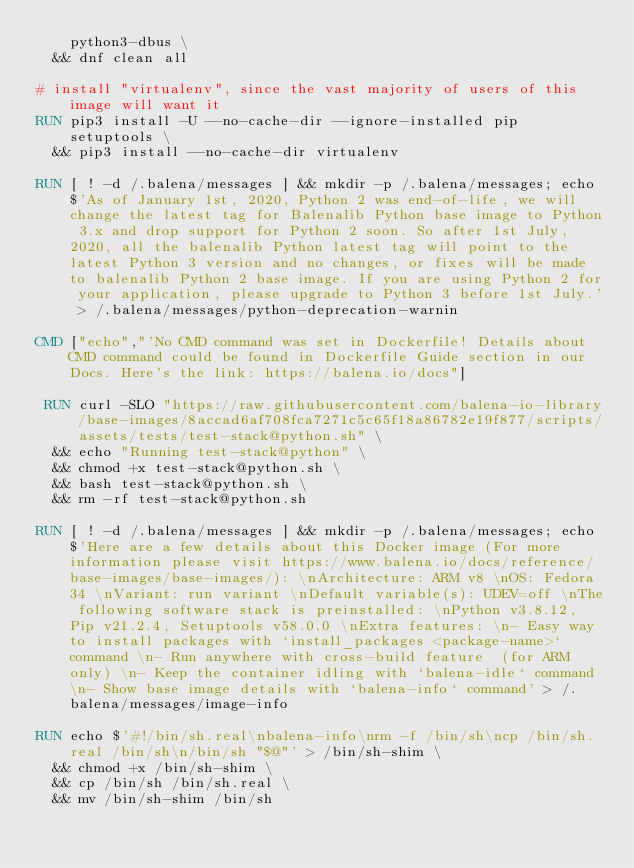<code> <loc_0><loc_0><loc_500><loc_500><_Dockerfile_>		python3-dbus \
	&& dnf clean all

# install "virtualenv", since the vast majority of users of this image will want it
RUN pip3 install -U --no-cache-dir --ignore-installed pip setuptools \
	&& pip3 install --no-cache-dir virtualenv

RUN [ ! -d /.balena/messages ] && mkdir -p /.balena/messages; echo $'As of January 1st, 2020, Python 2 was end-of-life, we will change the latest tag for Balenalib Python base image to Python 3.x and drop support for Python 2 soon. So after 1st July, 2020, all the balenalib Python latest tag will point to the latest Python 3 version and no changes, or fixes will be made to balenalib Python 2 base image. If you are using Python 2 for your application, please upgrade to Python 3 before 1st July.' > /.balena/messages/python-deprecation-warnin

CMD ["echo","'No CMD command was set in Dockerfile! Details about CMD command could be found in Dockerfile Guide section in our Docs. Here's the link: https://balena.io/docs"]

 RUN curl -SLO "https://raw.githubusercontent.com/balena-io-library/base-images/8accad6af708fca7271c5c65f18a86782e19f877/scripts/assets/tests/test-stack@python.sh" \
  && echo "Running test-stack@python" \
  && chmod +x test-stack@python.sh \
  && bash test-stack@python.sh \
  && rm -rf test-stack@python.sh 

RUN [ ! -d /.balena/messages ] && mkdir -p /.balena/messages; echo $'Here are a few details about this Docker image (For more information please visit https://www.balena.io/docs/reference/base-images/base-images/): \nArchitecture: ARM v8 \nOS: Fedora 34 \nVariant: run variant \nDefault variable(s): UDEV=off \nThe following software stack is preinstalled: \nPython v3.8.12, Pip v21.2.4, Setuptools v58.0.0 \nExtra features: \n- Easy way to install packages with `install_packages <package-name>` command \n- Run anywhere with cross-build feature  (for ARM only) \n- Keep the container idling with `balena-idle` command \n- Show base image details with `balena-info` command' > /.balena/messages/image-info

RUN echo $'#!/bin/sh.real\nbalena-info\nrm -f /bin/sh\ncp /bin/sh.real /bin/sh\n/bin/sh "$@"' > /bin/sh-shim \
	&& chmod +x /bin/sh-shim \
	&& cp /bin/sh /bin/sh.real \
	&& mv /bin/sh-shim /bin/sh</code> 